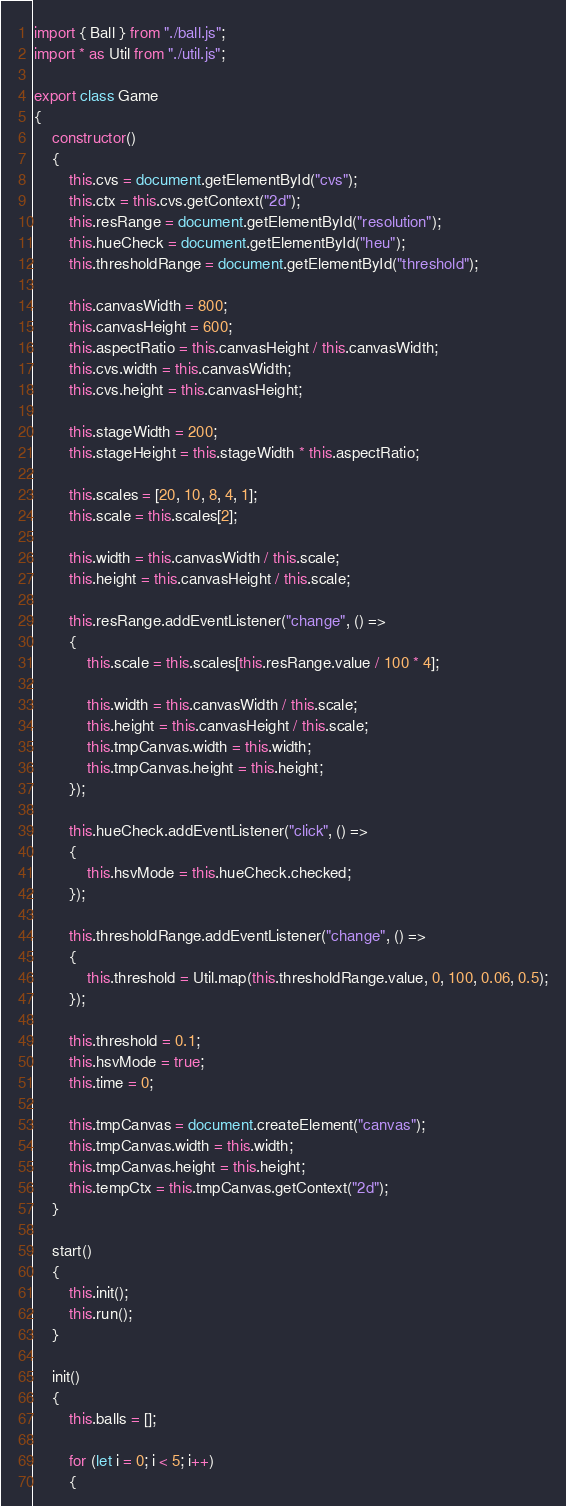Convert code to text. <code><loc_0><loc_0><loc_500><loc_500><_JavaScript_>import { Ball } from "./ball.js";
import * as Util from "./util.js";

export class Game
{
    constructor()
    {
        this.cvs = document.getElementById("cvs");
        this.ctx = this.cvs.getContext("2d");
        this.resRange = document.getElementById("resolution");
        this.hueCheck = document.getElementById("heu");
        this.thresholdRange = document.getElementById("threshold");

        this.canvasWidth = 800;
        this.canvasHeight = 600;
        this.aspectRatio = this.canvasHeight / this.canvasWidth;
        this.cvs.width = this.canvasWidth;
        this.cvs.height = this.canvasHeight;

        this.stageWidth = 200;
        this.stageHeight = this.stageWidth * this.aspectRatio;

        this.scales = [20, 10, 8, 4, 1];
        this.scale = this.scales[2];

        this.width = this.canvasWidth / this.scale;
        this.height = this.canvasHeight / this.scale;

        this.resRange.addEventListener("change", () =>
        {
            this.scale = this.scales[this.resRange.value / 100 * 4];

            this.width = this.canvasWidth / this.scale;
            this.height = this.canvasHeight / this.scale;
            this.tmpCanvas.width = this.width;
            this.tmpCanvas.height = this.height;
        });

        this.hueCheck.addEventListener("click", () =>
        {
            this.hsvMode = this.hueCheck.checked;
        });

        this.thresholdRange.addEventListener("change", () =>
        {
            this.threshold = Util.map(this.thresholdRange.value, 0, 100, 0.06, 0.5);
        });

        this.threshold = 0.1;
        this.hsvMode = true;
        this.time = 0;

        this.tmpCanvas = document.createElement("canvas");
        this.tmpCanvas.width = this.width;
        this.tmpCanvas.height = this.height;
        this.tempCtx = this.tmpCanvas.getContext("2d");
    }

    start()
    {
        this.init();
        this.run();
    }

    init()
    {
        this.balls = [];

        for (let i = 0; i < 5; i++)
        {</code> 